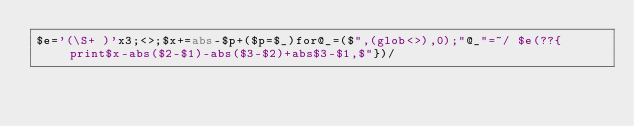Convert code to text. <code><loc_0><loc_0><loc_500><loc_500><_Perl_>$e='(\S+ )'x3;<>;$x+=abs-$p+($p=$_)for@_=($",(glob<>),0);"@_"=~/ $e(??{print$x-abs($2-$1)-abs($3-$2)+abs$3-$1,$"})/</code> 